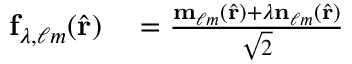<formula> <loc_0><loc_0><loc_500><loc_500>\begin{array} { r l } { f _ { \lambda , \ell m } ( \hat { r } ) } & = \frac { m _ { \ell m } ( \hat { r } ) + \lambda n _ { \ell m } ( \hat { r } ) } { \sqrt { 2 } } } \end{array}</formula> 